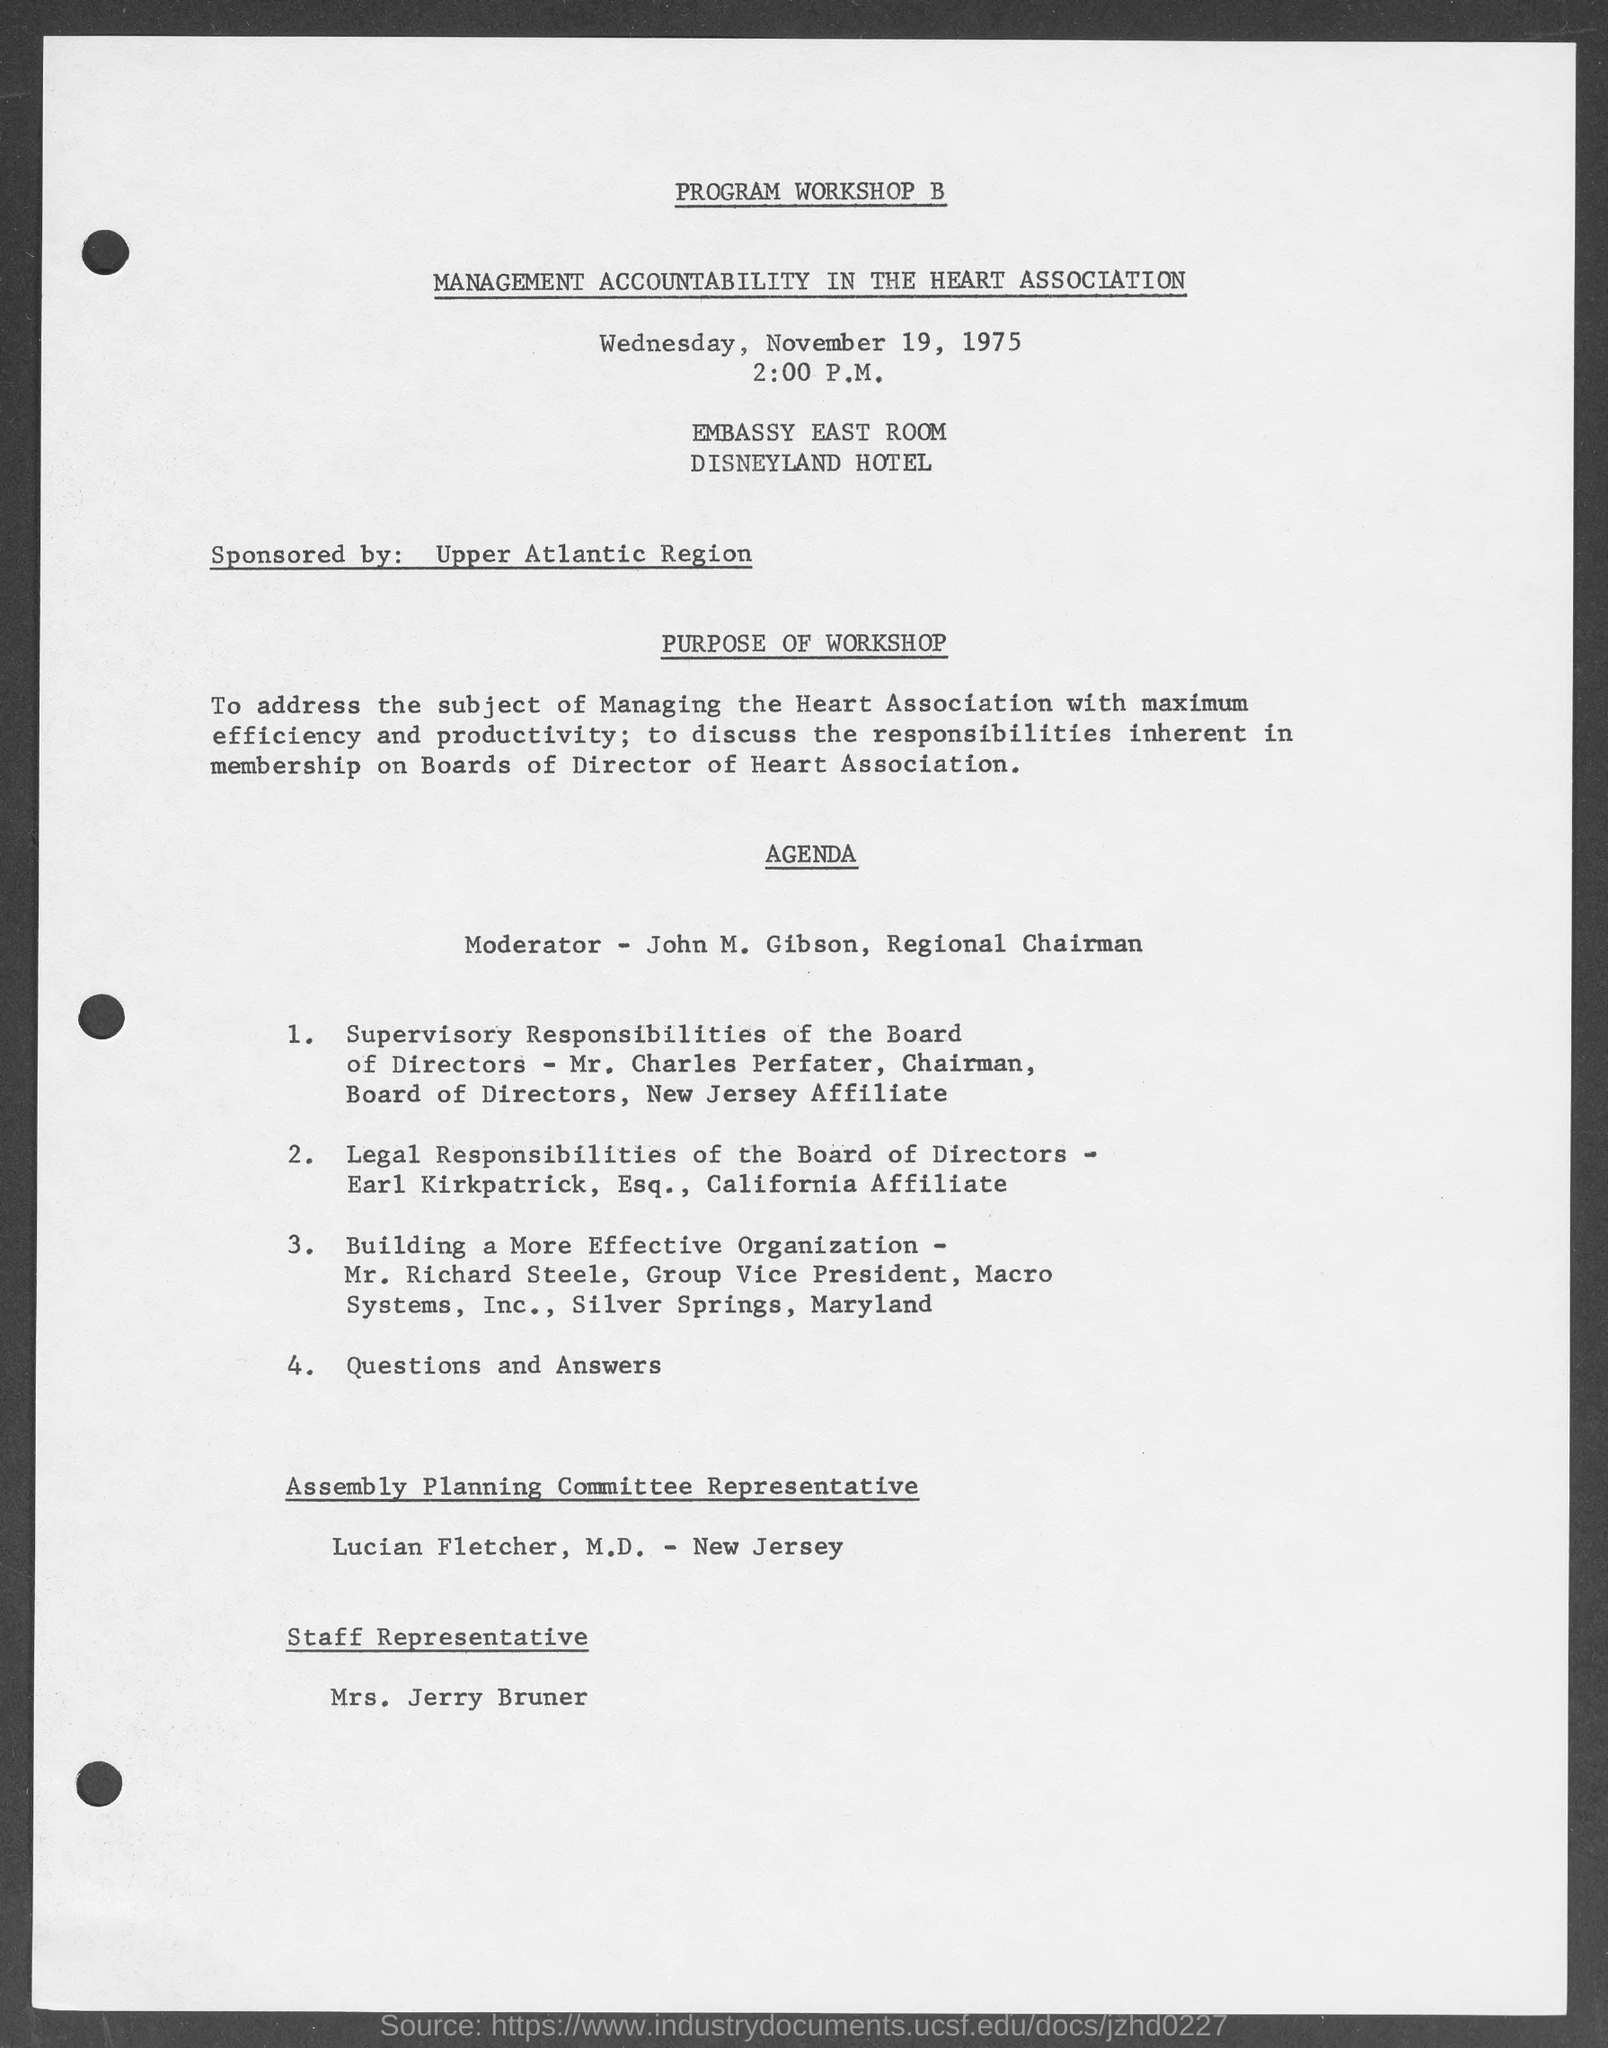What is the heading of document on top?
Offer a terse response. Program Workshop B. What day of the week is mentioned in the document?
Your answer should be very brief. Wednesday. What is the date mentioned in document?
Give a very brief answer. November 19, 1975. Who sponsored this program workshop?
Provide a short and direct response. Upper Atlantic Region. Who is the moderator mentioned in agenda?
Provide a succinct answer. John M. Gibson. What is the address of program workshop?
Provide a short and direct response. Embassy East room disneyland hotel. Who is assembly planning committee representative?
Keep it short and to the point. Lucian Fletcher, M.D. 